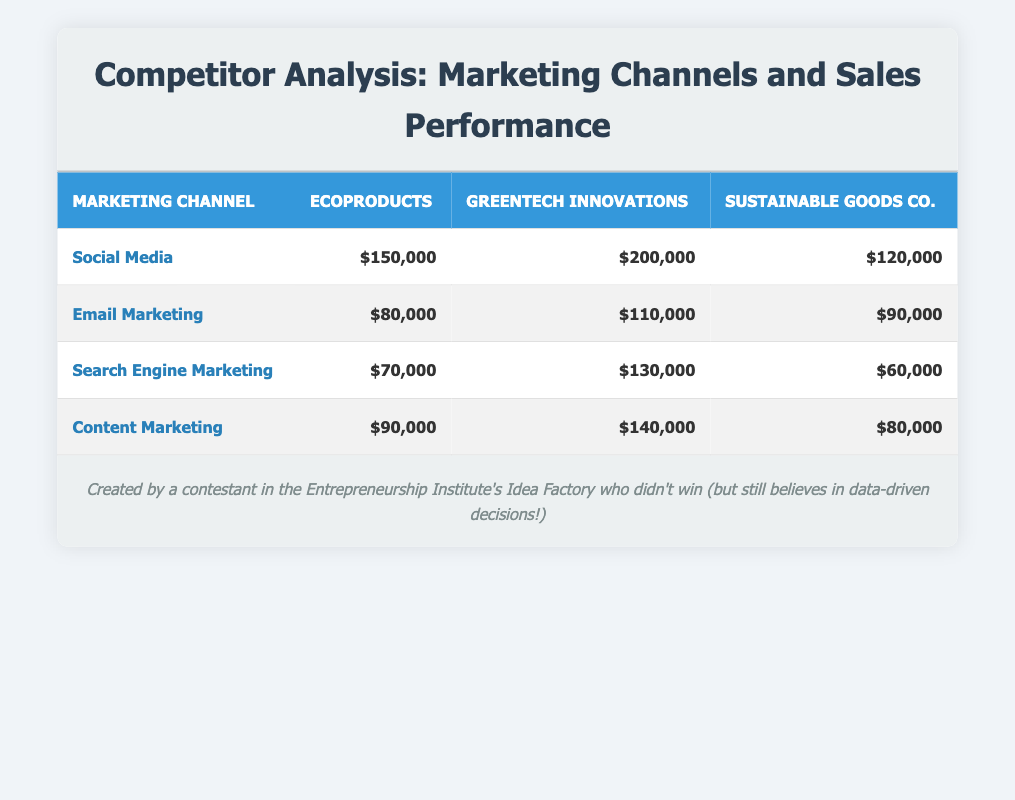What is the sales performance of GreenTech Innovations in the Social Media channel? The table shows the sales performance for GreenTech Innovations specifically in the Social Media channel, which is $200,000.
Answer: $200,000 Which marketing channel has the highest sales performance for EcoProducts? The highest sales performance for EcoProducts can be found by comparing the values across all channels. In the table, EcoProducts has $150,000 in Social Media, $80,000 in Email Marketing, $70,000 in Search Engine Marketing, and $90,000 in Content Marketing. The highest is $150,000 in Social Media.
Answer: $150,000 What is the average sales performance of Sustainable Goods Co. across all marketing channels? To calculate the average, first, sum the sales performances for Sustainable Goods Co. across all channels: $120,000 (Social Media) + $90,000 (Email Marketing) + $60,000 (Search Engine Marketing) + $80,000 (Content Marketing) = $350,000. Then divide by the number of channels, which is 4. Thus, the average is $350,000 / 4 = $87,500.
Answer: $87,500 Did EcoProducts perform better than Sustainable Goods Co. in all marketing channels? Looking at the table, EcoProducts sales in Social Media ($150,000) is higher than Sustainable Goods Co. ($120,000), in Email Marketing ($80,000), EcoProducts has a lower performance than Sustainable Goods Co. ($90,000). In Search Engine Marketing, EcoProducts ($70,000) is higher than Sustainable Goods Co. ($60,000), while in Content Marketing, EcoProducts ($90,000) is also higher than Sustainable Goods Co. ($80,000). Therefore, EcoProducts did not perform better in Email Marketing.
Answer: No What is the difference in sales performance between GreenTech Innovations and EcoProducts in Search Engine Marketing? In the Search Engine Marketing channel, GreenTech Innovations has sales of $130,000, while EcoProducts has $70,000. The difference is calculated as $130,000 - $70,000 = $60,000.
Answer: $60,000 